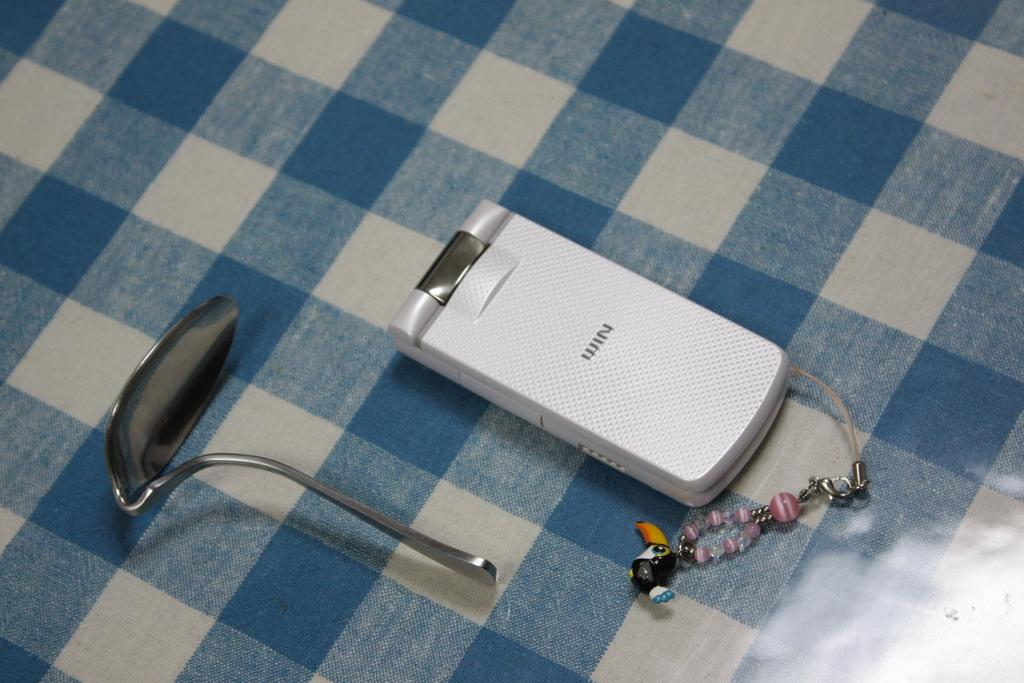<image>
Describe the image concisely. A WIN phone sits on a checked table cloth beside a spoon that is bent. 